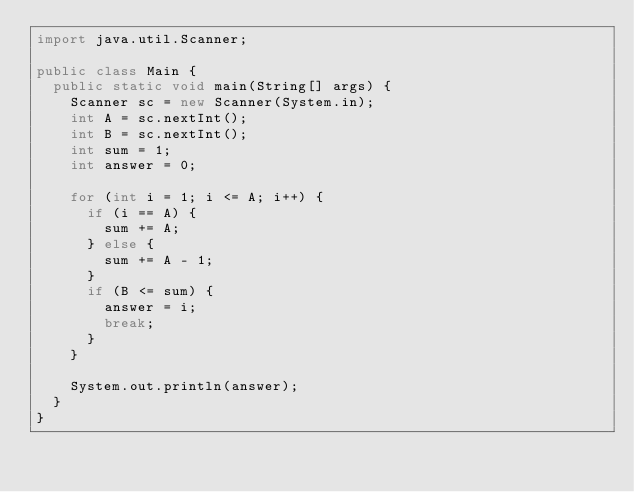Convert code to text. <code><loc_0><loc_0><loc_500><loc_500><_Java_>import java.util.Scanner;

public class Main {
	public static void main(String[] args) {
		Scanner sc = new Scanner(System.in);
		int A = sc.nextInt();
		int B = sc.nextInt();
		int sum = 1;
		int answer = 0;

		for (int i = 1; i <= A; i++) {
			if (i == A) {
				sum += A;
			} else {
				sum += A - 1;
			}
			if (B <= sum) {
				answer = i;
				break;
			}
		}

		System.out.println(answer);
	}
}
</code> 